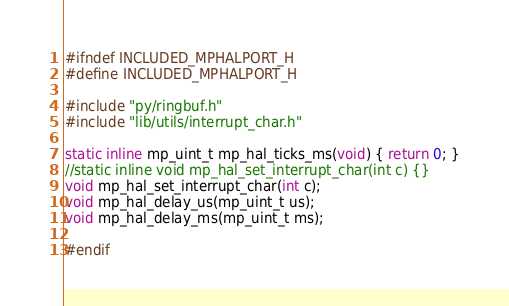Convert code to text. <code><loc_0><loc_0><loc_500><loc_500><_C_>
#ifndef INCLUDED_MPHALPORT_H
#define INCLUDED_MPHALPORT_H

#include "py/ringbuf.h"
#include "lib/utils/interrupt_char.h"

static inline mp_uint_t mp_hal_ticks_ms(void) { return 0; }
//static inline void mp_hal_set_interrupt_char(int c) {}
void mp_hal_set_interrupt_char(int c);
void mp_hal_delay_us(mp_uint_t us);
void mp_hal_delay_ms(mp_uint_t ms);

#endif

</code> 